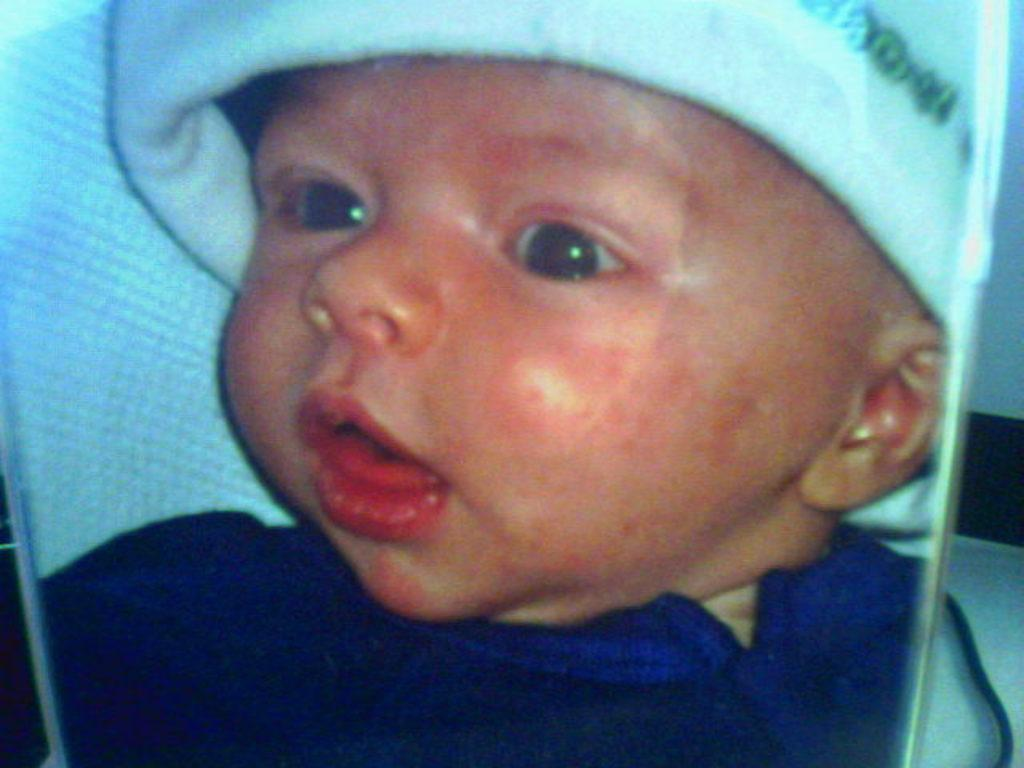What is the main subject in the foreground of the image? There is a photo of a baby in the foreground of the image. What type of lettuce is being used as a ring in the image? There is no lettuce or ring present in the image; it features a photo of a baby. 